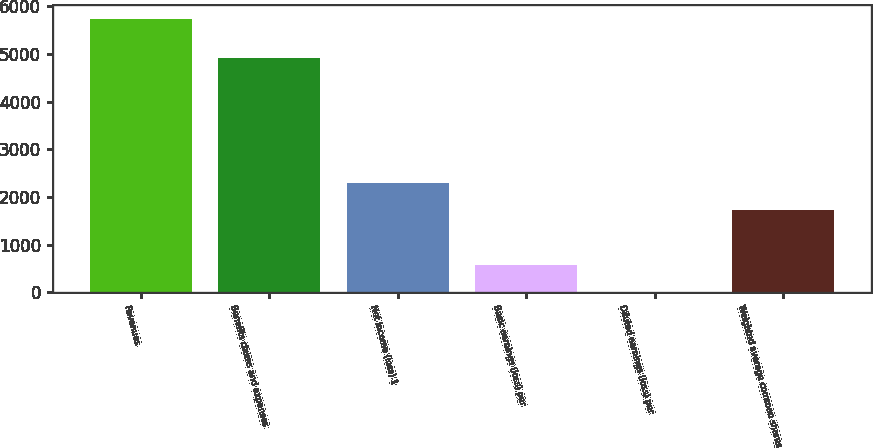Convert chart to OTSL. <chart><loc_0><loc_0><loc_500><loc_500><bar_chart><fcel>Revenues<fcel>Benefits claims and expenses<fcel>Net income (loss) 1<fcel>Basic earnings (loss) per<fcel>Diluted earnings (loss) per<fcel>Weighted average common shares<nl><fcel>5732<fcel>4914<fcel>2293.97<fcel>574.94<fcel>1.93<fcel>1720.96<nl></chart> 